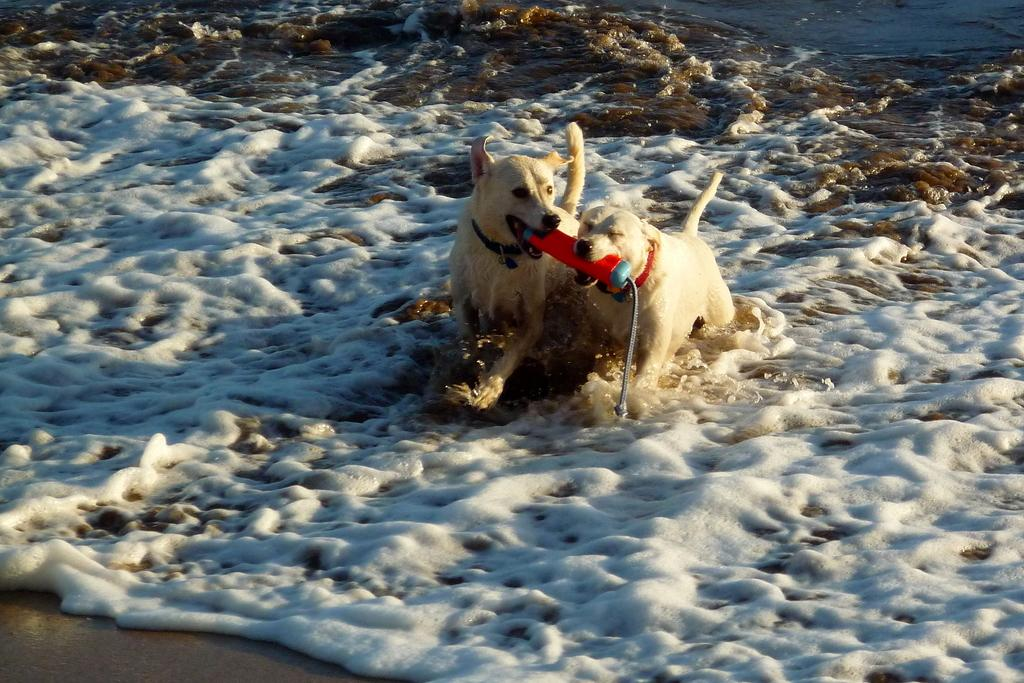How many dogs are in the image? There are two dogs in the image. Where are the dogs located in the image? The dogs are in the water. What color are the dogs? The dogs are cream-colored. Can you identify any other objects in the image based on their color? Yes, there is an object in the image that is red in color. What type of store can be seen in the background of the image? There is no store visible in the image; it features two dogs in the water. What kind of beast is present in the image? There are no beasts present in the image; it features two dogs. 